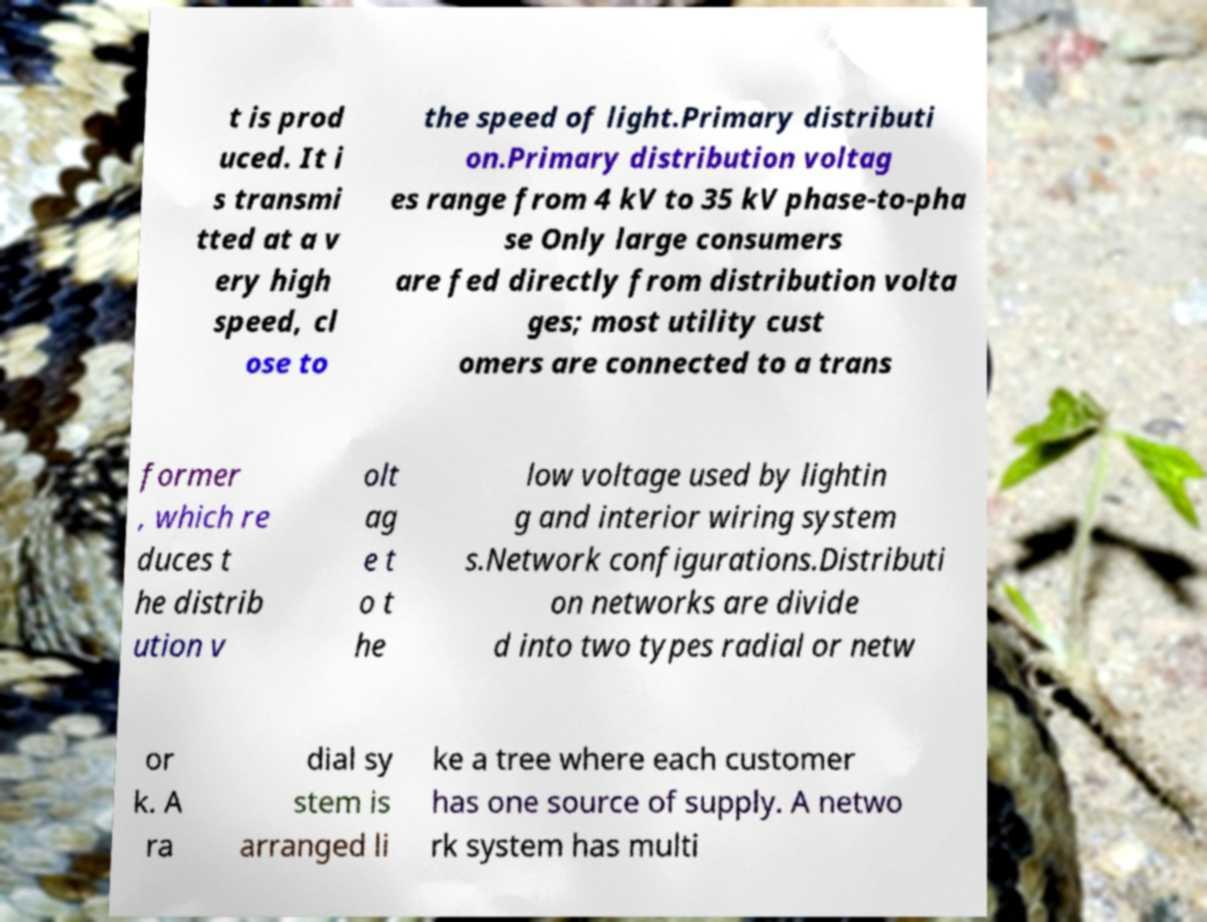Could you extract and type out the text from this image? t is prod uced. It i s transmi tted at a v ery high speed, cl ose to the speed of light.Primary distributi on.Primary distribution voltag es range from 4 kV to 35 kV phase-to-pha se Only large consumers are fed directly from distribution volta ges; most utility cust omers are connected to a trans former , which re duces t he distrib ution v olt ag e t o t he low voltage used by lightin g and interior wiring system s.Network configurations.Distributi on networks are divide d into two types radial or netw or k. A ra dial sy stem is arranged li ke a tree where each customer has one source of supply. A netwo rk system has multi 